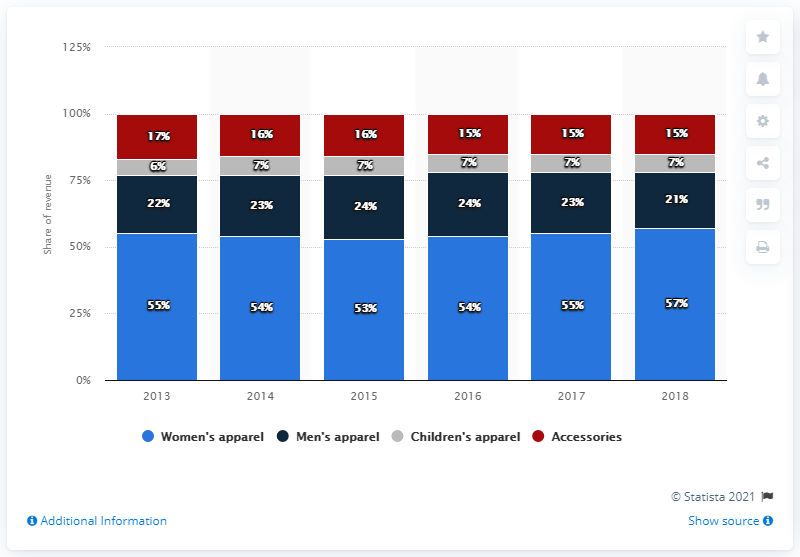List a handful of essential elements in this visual. In 2018, the ratio between women's apparel and men's apparel was 2.71, indicating that women's apparel accounted for 2.71 times more sales than men's apparel. The blue bar refers to women's apparel data. 